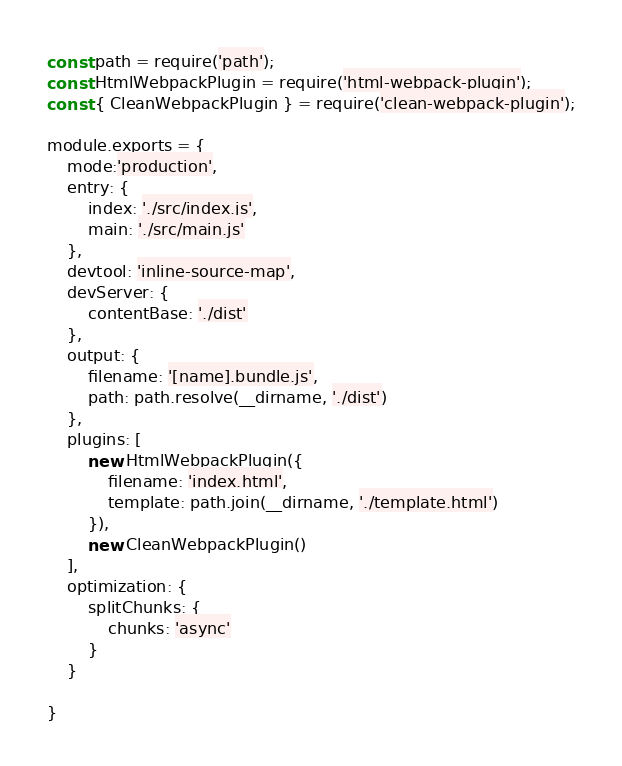Convert code to text. <code><loc_0><loc_0><loc_500><loc_500><_JavaScript_>const path = require('path');
const HtmlWebpackPlugin = require('html-webpack-plugin');
const { CleanWebpackPlugin } = require('clean-webpack-plugin');

module.exports = {
    mode:'production',
    entry: {
        index: './src/index.js',
        main: './src/main.js'
    },
    devtool: 'inline-source-map',
    devServer: {
        contentBase: './dist'
    },
    output: {
        filename: '[name].bundle.js',
        path: path.resolve(__dirname, './dist')
    },
    plugins: [
        new HtmlWebpackPlugin({
            filename: 'index.html',
            template: path.join(__dirname, './template.html')
        }),
        new CleanWebpackPlugin()
    ],
    optimization: {
        splitChunks: {
            chunks: 'async'
        }
    }

}</code> 